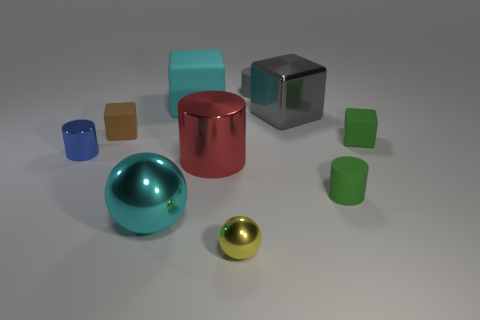Subtract all red shiny cylinders. How many cylinders are left? 3 Subtract all green cubes. How many cubes are left? 3 Subtract 3 cubes. How many cubes are left? 1 Subtract all gray spheres. Subtract all gray cylinders. How many spheres are left? 2 Subtract all balls. How many objects are left? 8 Subtract all big gray things. Subtract all objects. How many objects are left? 8 Add 5 tiny brown blocks. How many tiny brown blocks are left? 6 Add 3 large spheres. How many large spheres exist? 4 Subtract 1 blue cylinders. How many objects are left? 9 